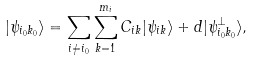Convert formula to latex. <formula><loc_0><loc_0><loc_500><loc_500>| \psi _ { i _ { 0 } k _ { 0 } } \rangle = \sum _ { i \neq i _ { 0 } } \sum _ { k = 1 } ^ { m _ { i } } C _ { i k } | \psi _ { i k } \rangle + d | \psi _ { i _ { 0 } k _ { 0 } } ^ { \perp } \rangle ,</formula> 